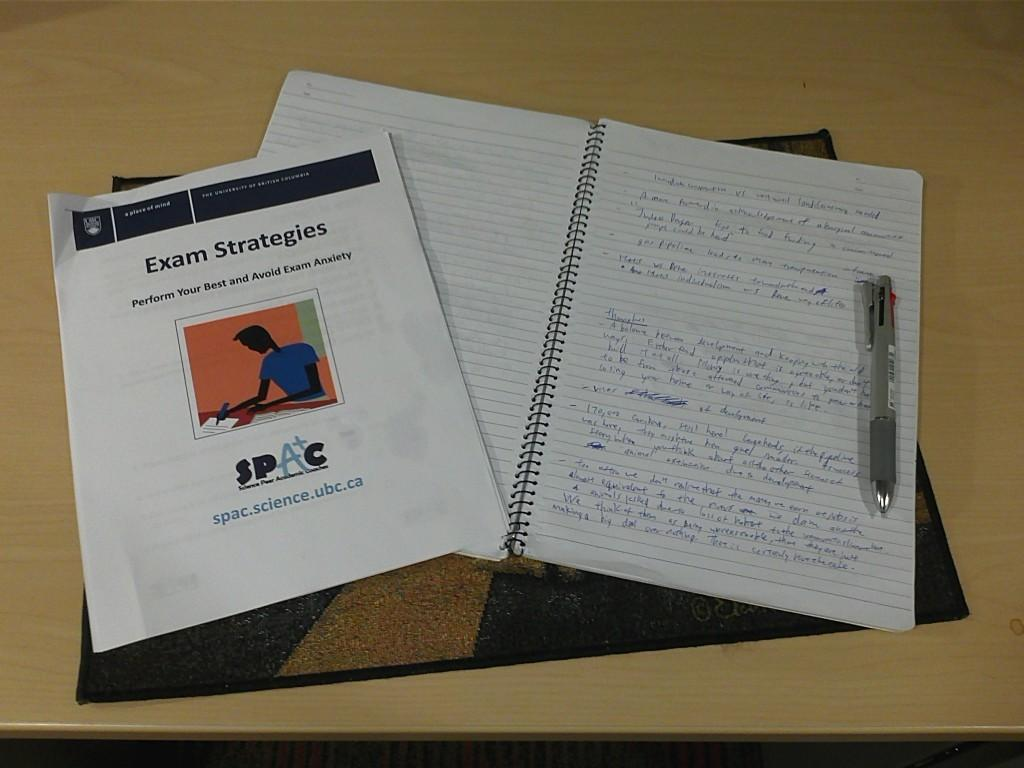<image>
Present a compact description of the photo's key features. A pamphlet titled Exam Strategies is on top of a notebook. 